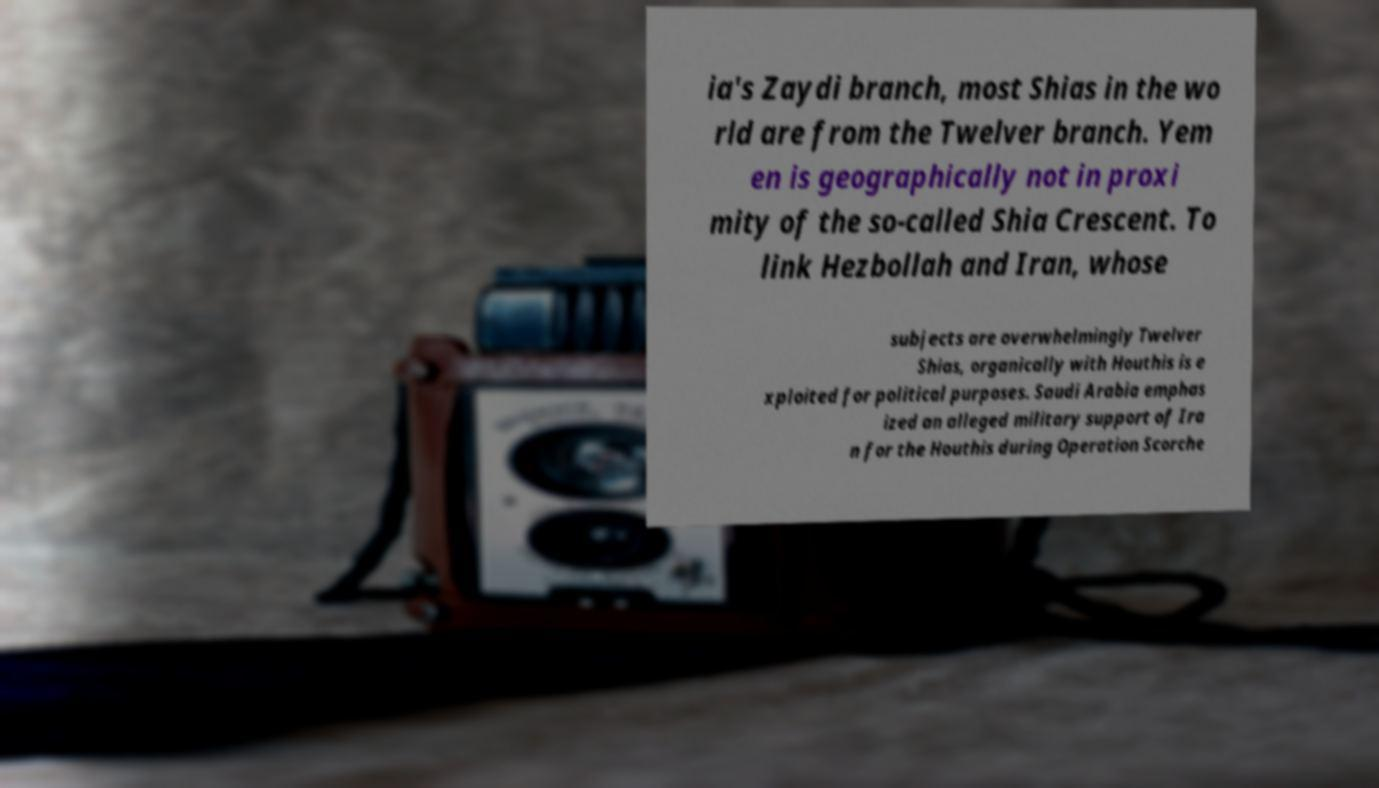For documentation purposes, I need the text within this image transcribed. Could you provide that? ia's Zaydi branch, most Shias in the wo rld are from the Twelver branch. Yem en is geographically not in proxi mity of the so-called Shia Crescent. To link Hezbollah and Iran, whose subjects are overwhelmingly Twelver Shias, organically with Houthis is e xploited for political purposes. Saudi Arabia emphas ized an alleged military support of Ira n for the Houthis during Operation Scorche 